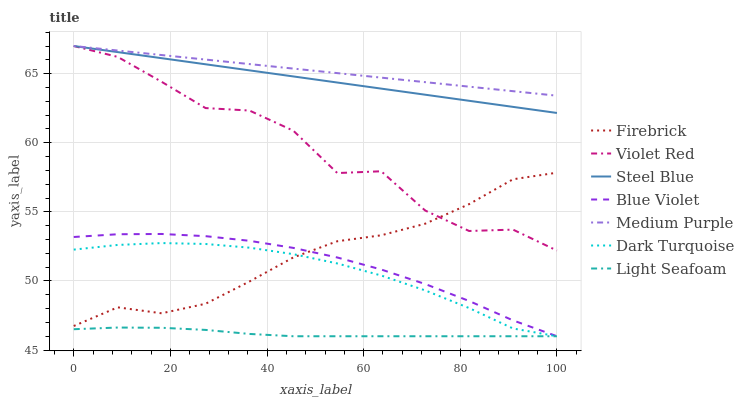Does Dark Turquoise have the minimum area under the curve?
Answer yes or no. No. Does Dark Turquoise have the maximum area under the curve?
Answer yes or no. No. Is Dark Turquoise the smoothest?
Answer yes or no. No. Is Dark Turquoise the roughest?
Answer yes or no. No. Does Firebrick have the lowest value?
Answer yes or no. No. Does Dark Turquoise have the highest value?
Answer yes or no. No. Is Light Seafoam less than Steel Blue?
Answer yes or no. Yes. Is Violet Red greater than Dark Turquoise?
Answer yes or no. Yes. Does Light Seafoam intersect Steel Blue?
Answer yes or no. No. 